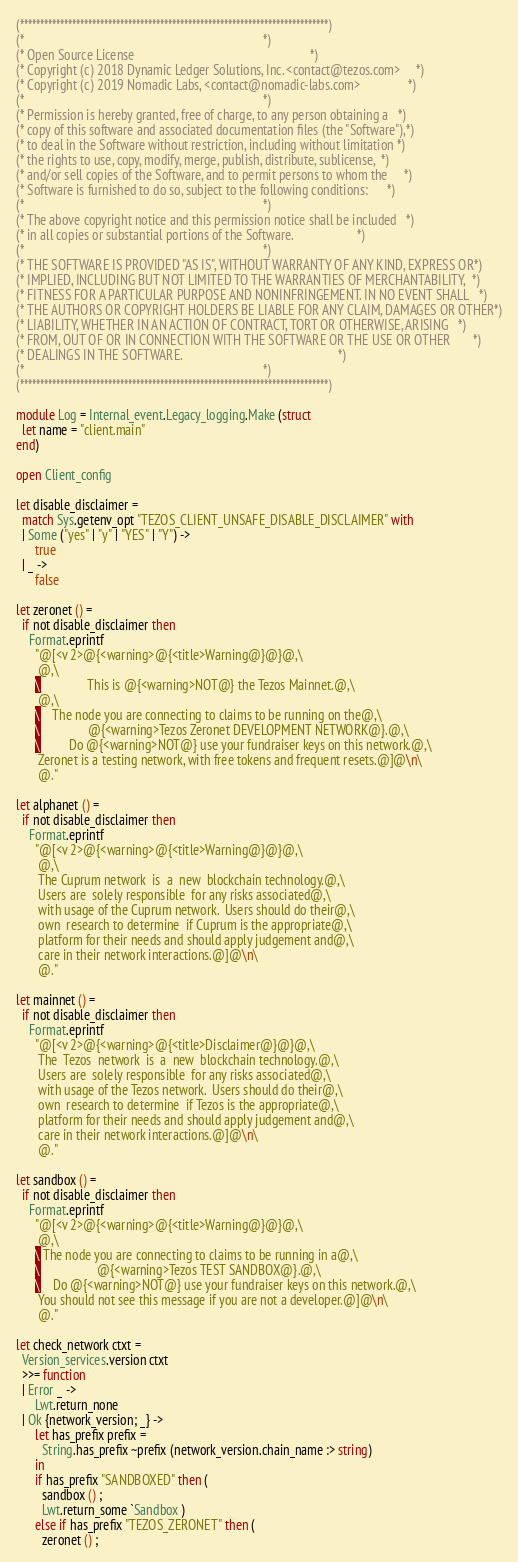<code> <loc_0><loc_0><loc_500><loc_500><_OCaml_>(*****************************************************************************)
(*                                                                           *)
(* Open Source License                                                       *)
(* Copyright (c) 2018 Dynamic Ledger Solutions, Inc. <contact@tezos.com>     *)
(* Copyright (c) 2019 Nomadic Labs, <contact@nomadic-labs.com>               *)
(*                                                                           *)
(* Permission is hereby granted, free of charge, to any person obtaining a   *)
(* copy of this software and associated documentation files (the "Software"),*)
(* to deal in the Software without restriction, including without limitation *)
(* the rights to use, copy, modify, merge, publish, distribute, sublicense,  *)
(* and/or sell copies of the Software, and to permit persons to whom the     *)
(* Software is furnished to do so, subject to the following conditions:      *)
(*                                                                           *)
(* The above copyright notice and this permission notice shall be included   *)
(* in all copies or substantial portions of the Software.                    *)
(*                                                                           *)
(* THE SOFTWARE IS PROVIDED "AS IS", WITHOUT WARRANTY OF ANY KIND, EXPRESS OR*)
(* IMPLIED, INCLUDING BUT NOT LIMITED TO THE WARRANTIES OF MERCHANTABILITY,  *)
(* FITNESS FOR A PARTICULAR PURPOSE AND NONINFRINGEMENT. IN NO EVENT SHALL   *)
(* THE AUTHORS OR COPYRIGHT HOLDERS BE LIABLE FOR ANY CLAIM, DAMAGES OR OTHER*)
(* LIABILITY, WHETHER IN AN ACTION OF CONTRACT, TORT OR OTHERWISE, ARISING   *)
(* FROM, OUT OF OR IN CONNECTION WITH THE SOFTWARE OR THE USE OR OTHER       *)
(* DEALINGS IN THE SOFTWARE.                                                 *)
(*                                                                           *)
(*****************************************************************************)

module Log = Internal_event.Legacy_logging.Make (struct
  let name = "client.main"
end)

open Client_config

let disable_disclaimer =
  match Sys.getenv_opt "TEZOS_CLIENT_UNSAFE_DISABLE_DISCLAIMER" with
  | Some ("yes" | "y" | "YES" | "Y") ->
      true
  | _ ->
      false

let zeronet () =
  if not disable_disclaimer then
    Format.eprintf
      "@[<v 2>@{<warning>@{<title>Warning@}@}@,\
       @,\
      \               This is @{<warning>NOT@} the Tezos Mainnet.@,\
       @,\
      \    The node you are connecting to claims to be running on the@,\
      \               @{<warning>Tezos Zeronet DEVELOPMENT NETWORK@}.@,\
      \         Do @{<warning>NOT@} use your fundraiser keys on this network.@,\
       Zeronet is a testing network, with free tokens and frequent resets.@]@\n\
       @."

let alphanet () =
  if not disable_disclaimer then
    Format.eprintf
      "@[<v 2>@{<warning>@{<title>Warning@}@}@,\
       @,\
       The Cuprum network  is  a  new  blockchain technology.@,\
       Users are  solely responsible  for any risks associated@,\
       with usage of the Cuprum network.  Users should do their@,\
       own  research to determine  if Cuprum is the appropriate@,\
       platform for their needs and should apply judgement and@,\
       care in their network interactions.@]@\n\
       @."

let mainnet () =
  if not disable_disclaimer then
    Format.eprintf
      "@[<v 2>@{<warning>@{<title>Disclaimer@}@}@,\
       The  Tezos  network  is  a  new  blockchain technology.@,\
       Users are  solely responsible  for any risks associated@,\
       with usage of the Tezos network.  Users should do their@,\
       own  research to determine  if Tezos is the appropriate@,\
       platform for their needs and should apply judgement and@,\
       care in their network interactions.@]@\n\
       @."

let sandbox () =
  if not disable_disclaimer then
    Format.eprintf
      "@[<v 2>@{<warning>@{<title>Warning@}@}@,\
       @,\
      \ The node you are connecting to claims to be running in a@,\
      \                  @{<warning>Tezos TEST SANDBOX@}.@,\
      \    Do @{<warning>NOT@} use your fundraiser keys on this network.@,\
       You should not see this message if you are not a developer.@]@\n\
       @."

let check_network ctxt =
  Version_services.version ctxt
  >>= function
  | Error _ ->
      Lwt.return_none
  | Ok {network_version; _} ->
      let has_prefix prefix =
        String.has_prefix ~prefix (network_version.chain_name :> string)
      in
      if has_prefix "SANDBOXED" then (
        sandbox () ;
        Lwt.return_some `Sandbox )
      else if has_prefix "TEZOS_ZERONET" then (
        zeronet () ;</code> 